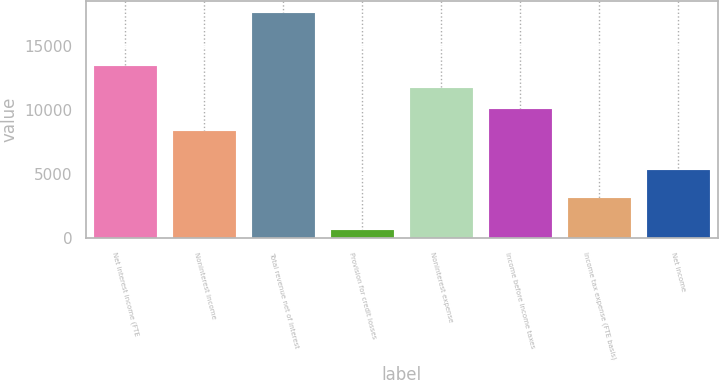Convert chart to OTSL. <chart><loc_0><loc_0><loc_500><loc_500><bar_chart><fcel>Net interest income (FTE<fcel>Noninterest income<fcel>Total revenue net of interest<fcel>Provision for credit losses<fcel>Noninterest expense<fcel>Income before income taxes<fcel>Income tax expense (FTE basis)<fcel>Net income<nl><fcel>13457.5<fcel>8377<fcel>17621<fcel>686<fcel>11764<fcel>10070.5<fcel>3114<fcel>5339<nl></chart> 